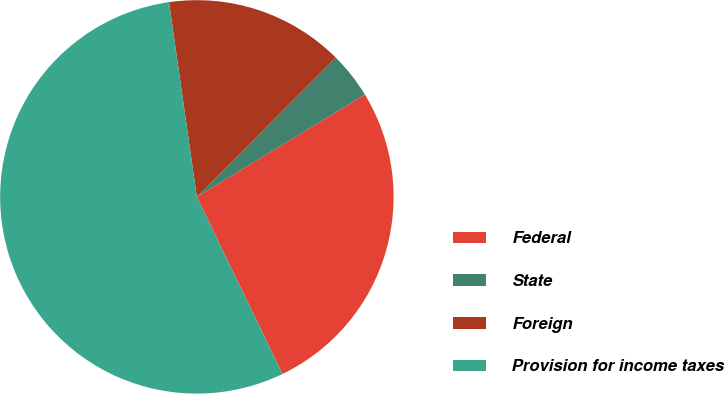Convert chart. <chart><loc_0><loc_0><loc_500><loc_500><pie_chart><fcel>Federal<fcel>State<fcel>Foreign<fcel>Provision for income taxes<nl><fcel>26.54%<fcel>3.83%<fcel>14.73%<fcel>54.9%<nl></chart> 